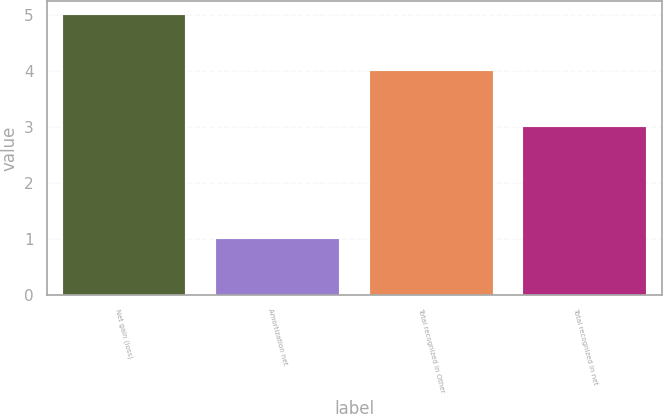Convert chart to OTSL. <chart><loc_0><loc_0><loc_500><loc_500><bar_chart><fcel>Net gain (loss)<fcel>Amortization net<fcel>Total recognized in Other<fcel>Total recognized in net<nl><fcel>5<fcel>1<fcel>4<fcel>3<nl></chart> 